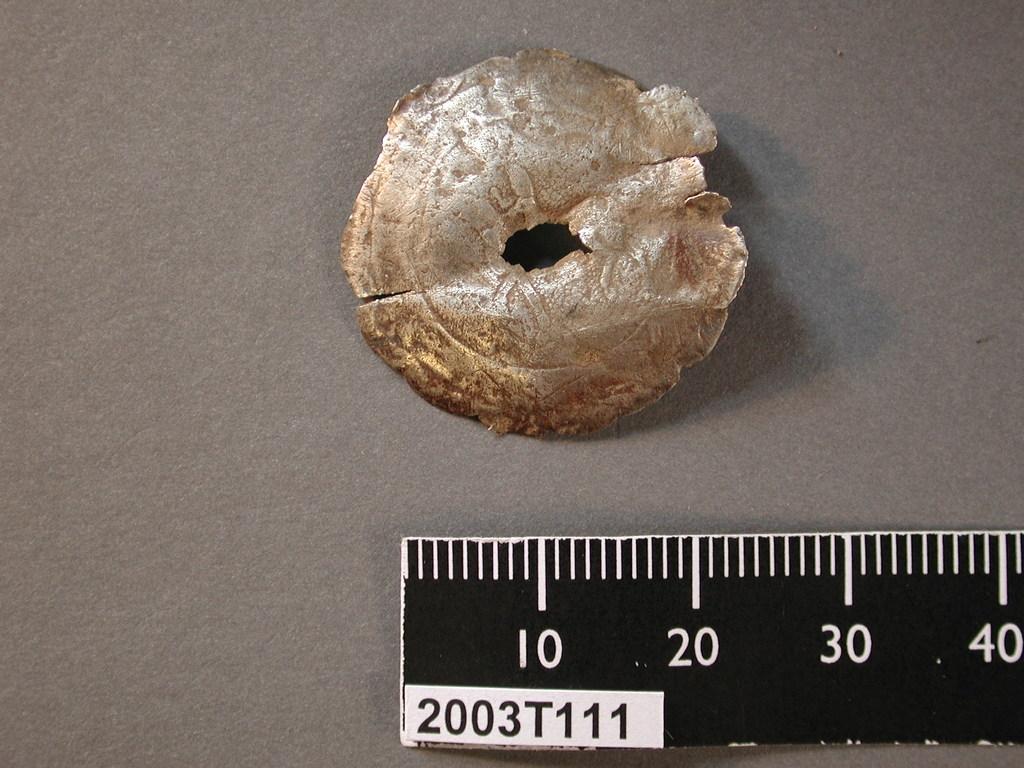What is the code on this ruler?
Keep it short and to the point. 2003t111. What is the code displayed on the ruler?
Offer a very short reply. 2003t111. 